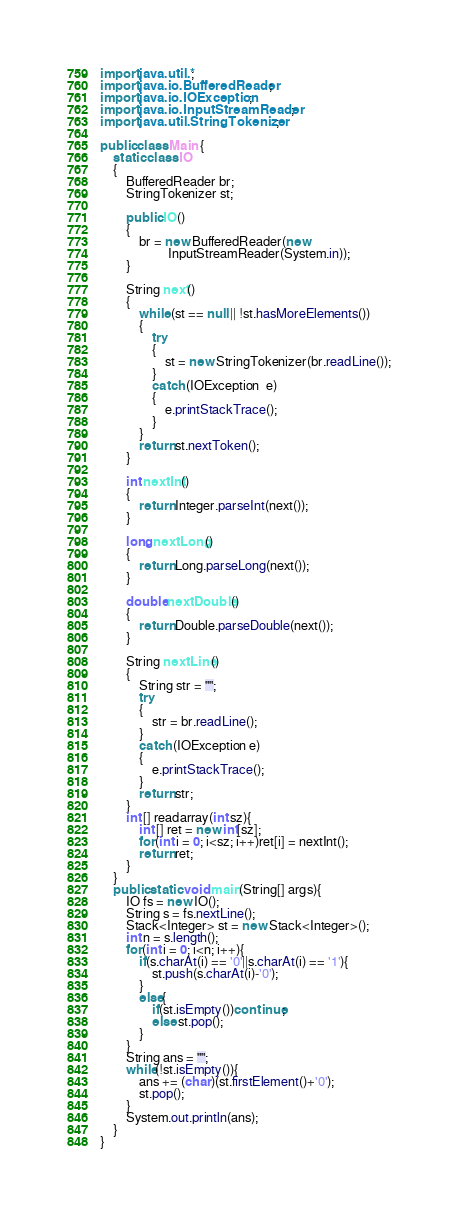<code> <loc_0><loc_0><loc_500><loc_500><_Java_>import java.util.*;
import java.io.BufferedReader; 
import java.io.IOException; 
import java.io.InputStreamReader; 
import java.util.StringTokenizer;

public class Main {
	static class IO 
    { 
        BufferedReader br; 
        StringTokenizer st; 
  
        public IO() 
        { 
            br = new BufferedReader(new
                     InputStreamReader(System.in)); 
        } 
  
        String next() 
        { 
            while (st == null || !st.hasMoreElements()) 
            { 
                try
                { 
                    st = new StringTokenizer(br.readLine()); 
                } 
                catch (IOException  e) 
                { 
                    e.printStackTrace(); 
                } 
            } 
            return st.nextToken(); 
        } 
  
        int nextInt() 
        { 
            return Integer.parseInt(next()); 
        } 
  
        long nextLong() 
        { 
            return Long.parseLong(next()); 
        } 
  
        double nextDouble() 
        { 
            return Double.parseDouble(next()); 
        } 
  
        String nextLine() 
        { 
            String str = ""; 
            try
            { 
                str = br.readLine(); 
            } 
            catch (IOException e) 
            { 
                e.printStackTrace(); 
            } 
            return str; 
        } 
        int [] readarray(int sz){
            int [] ret = new int[sz];
            for(int i = 0; i<sz; i++)ret[i] = nextInt();
            return ret;
        }
    } 
    public static void main(String[] args){
        IO fs = new IO();
        String s = fs.nextLine();
        Stack<Integer> st = new Stack<Integer>();
        int n = s.length();
        for(int i = 0; i<n; i++){
            if(s.charAt(i) == '0'||s.charAt(i) == '1'){
                st.push(s.charAt(i)-'0');
            }
            else{
                if(st.isEmpty())continue;
                else st.pop();
            }
        }
        String ans = "";
        while(!st.isEmpty()){
            ans += (char)(st.firstElement()+'0');
            st.pop();
        }
        System.out.println(ans);
    }
}
</code> 